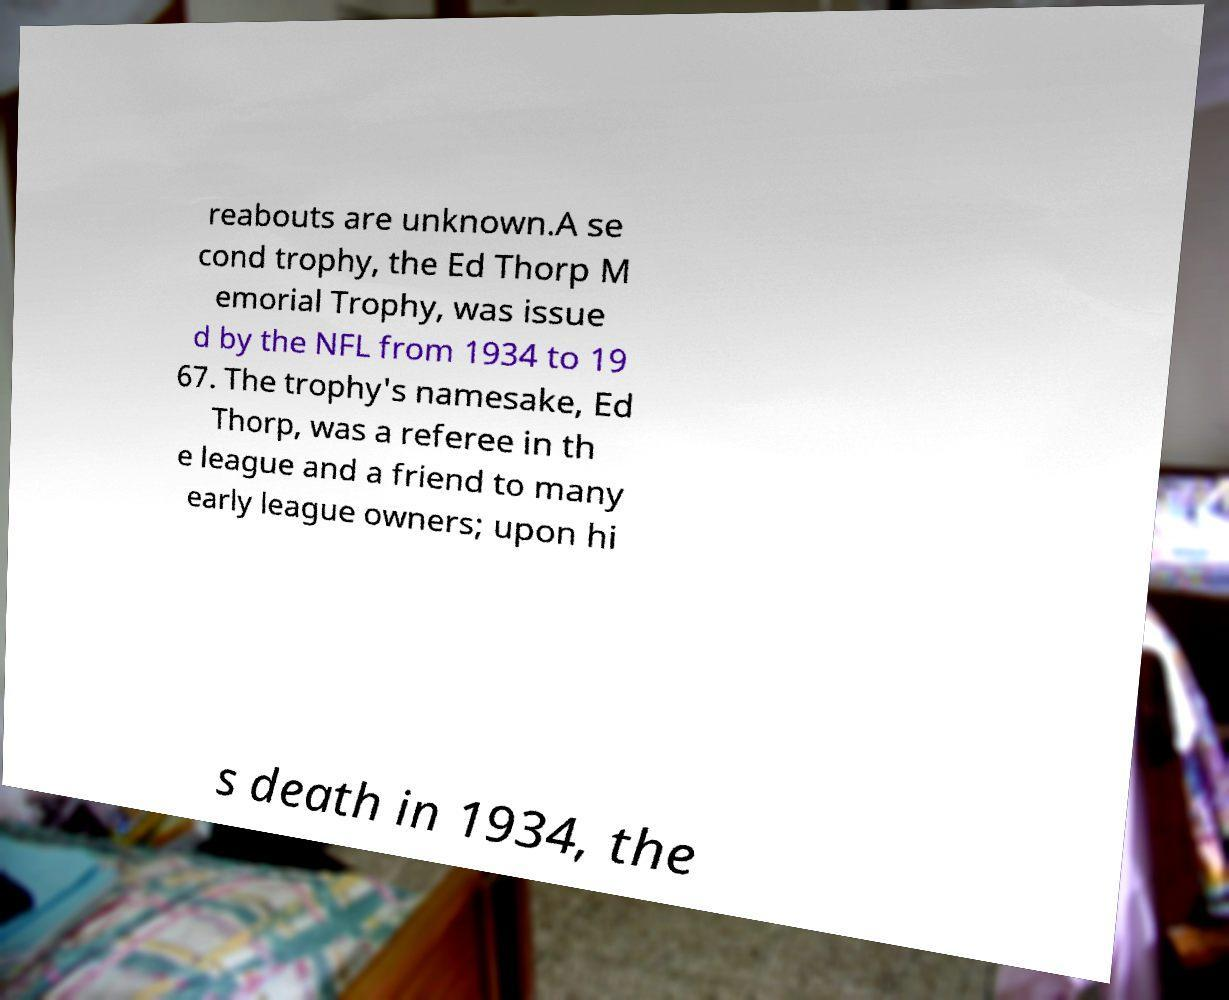For documentation purposes, I need the text within this image transcribed. Could you provide that? reabouts are unknown.A se cond trophy, the Ed Thorp M emorial Trophy, was issue d by the NFL from 1934 to 19 67. The trophy's namesake, Ed Thorp, was a referee in th e league and a friend to many early league owners; upon hi s death in 1934, the 